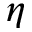Convert formula to latex. <formula><loc_0><loc_0><loc_500><loc_500>\eta</formula> 